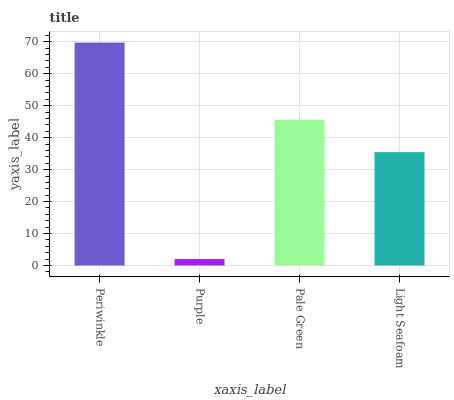Is Purple the minimum?
Answer yes or no. Yes. Is Periwinkle the maximum?
Answer yes or no. Yes. Is Pale Green the minimum?
Answer yes or no. No. Is Pale Green the maximum?
Answer yes or no. No. Is Pale Green greater than Purple?
Answer yes or no. Yes. Is Purple less than Pale Green?
Answer yes or no. Yes. Is Purple greater than Pale Green?
Answer yes or no. No. Is Pale Green less than Purple?
Answer yes or no. No. Is Pale Green the high median?
Answer yes or no. Yes. Is Light Seafoam the low median?
Answer yes or no. Yes. Is Light Seafoam the high median?
Answer yes or no. No. Is Pale Green the low median?
Answer yes or no. No. 